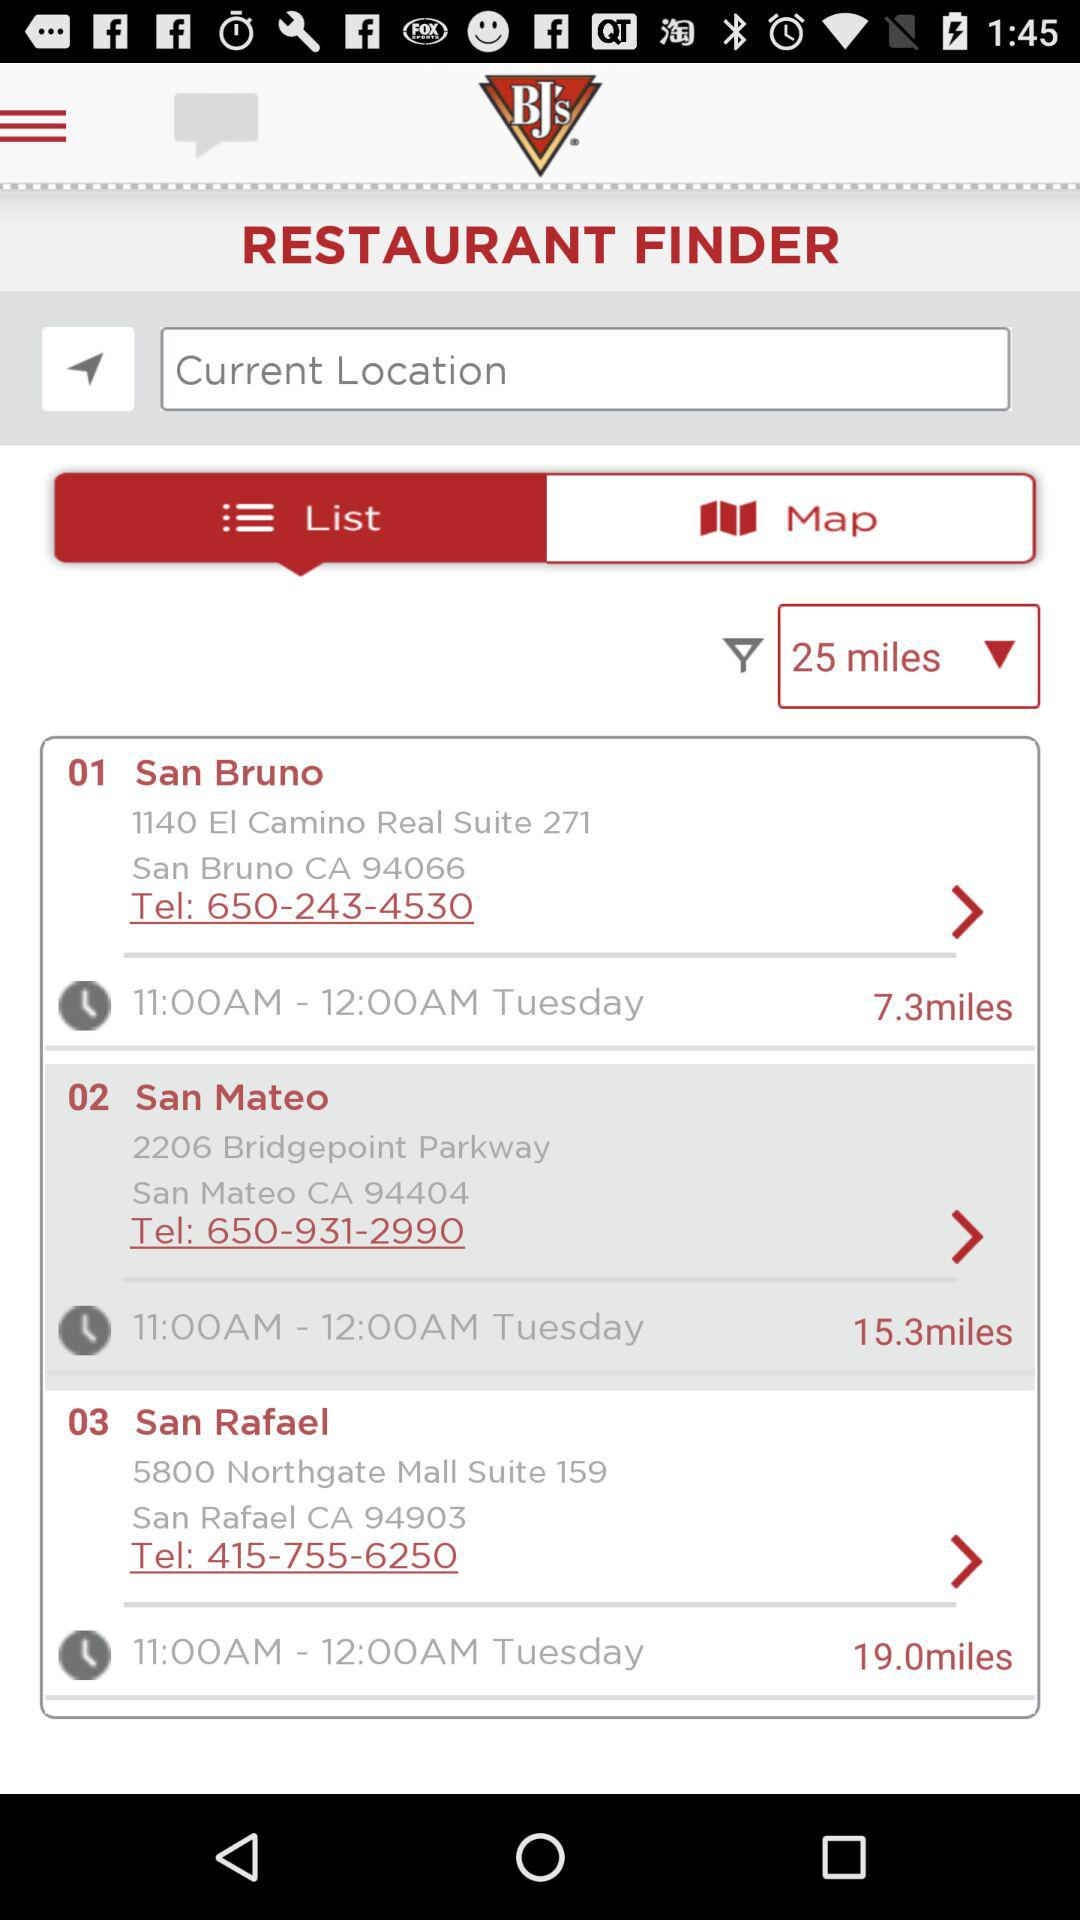What is the name of the application? The application name is "BJ’s Mobile App". 